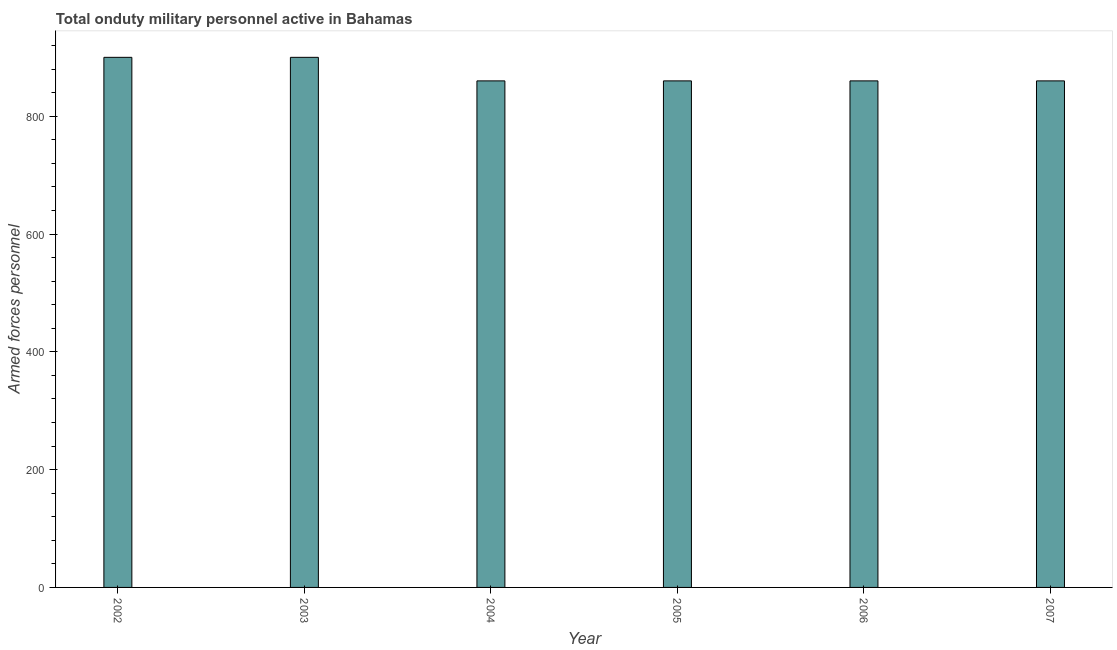Does the graph contain any zero values?
Offer a very short reply. No. Does the graph contain grids?
Offer a terse response. No. What is the title of the graph?
Your response must be concise. Total onduty military personnel active in Bahamas. What is the label or title of the Y-axis?
Provide a short and direct response. Armed forces personnel. What is the number of armed forces personnel in 2003?
Your answer should be very brief. 900. Across all years, what is the maximum number of armed forces personnel?
Provide a succinct answer. 900. Across all years, what is the minimum number of armed forces personnel?
Make the answer very short. 860. In which year was the number of armed forces personnel maximum?
Offer a very short reply. 2002. What is the sum of the number of armed forces personnel?
Keep it short and to the point. 5240. What is the difference between the number of armed forces personnel in 2002 and 2003?
Ensure brevity in your answer.  0. What is the average number of armed forces personnel per year?
Your response must be concise. 873. What is the median number of armed forces personnel?
Give a very brief answer. 860. Do a majority of the years between 2006 and 2005 (inclusive) have number of armed forces personnel greater than 40 ?
Give a very brief answer. No. What is the ratio of the number of armed forces personnel in 2003 to that in 2004?
Your answer should be compact. 1.05. Is the number of armed forces personnel in 2003 less than that in 2007?
Make the answer very short. No. How many bars are there?
Provide a succinct answer. 6. Are all the bars in the graph horizontal?
Provide a short and direct response. No. What is the difference between two consecutive major ticks on the Y-axis?
Your response must be concise. 200. Are the values on the major ticks of Y-axis written in scientific E-notation?
Provide a succinct answer. No. What is the Armed forces personnel in 2002?
Your answer should be compact. 900. What is the Armed forces personnel of 2003?
Make the answer very short. 900. What is the Armed forces personnel in 2004?
Give a very brief answer. 860. What is the Armed forces personnel in 2005?
Offer a terse response. 860. What is the Armed forces personnel in 2006?
Your response must be concise. 860. What is the Armed forces personnel in 2007?
Your answer should be compact. 860. What is the difference between the Armed forces personnel in 2002 and 2007?
Ensure brevity in your answer.  40. What is the difference between the Armed forces personnel in 2003 and 2004?
Make the answer very short. 40. What is the difference between the Armed forces personnel in 2003 and 2005?
Your answer should be very brief. 40. What is the difference between the Armed forces personnel in 2003 and 2007?
Ensure brevity in your answer.  40. What is the difference between the Armed forces personnel in 2004 and 2005?
Your answer should be very brief. 0. What is the difference between the Armed forces personnel in 2005 and 2006?
Give a very brief answer. 0. What is the ratio of the Armed forces personnel in 2002 to that in 2004?
Offer a terse response. 1.05. What is the ratio of the Armed forces personnel in 2002 to that in 2005?
Provide a short and direct response. 1.05. What is the ratio of the Armed forces personnel in 2002 to that in 2006?
Offer a very short reply. 1.05. What is the ratio of the Armed forces personnel in 2002 to that in 2007?
Provide a short and direct response. 1.05. What is the ratio of the Armed forces personnel in 2003 to that in 2004?
Make the answer very short. 1.05. What is the ratio of the Armed forces personnel in 2003 to that in 2005?
Make the answer very short. 1.05. What is the ratio of the Armed forces personnel in 2003 to that in 2006?
Keep it short and to the point. 1.05. What is the ratio of the Armed forces personnel in 2003 to that in 2007?
Make the answer very short. 1.05. What is the ratio of the Armed forces personnel in 2004 to that in 2005?
Ensure brevity in your answer.  1. What is the ratio of the Armed forces personnel in 2004 to that in 2006?
Your answer should be compact. 1. What is the ratio of the Armed forces personnel in 2005 to that in 2006?
Your answer should be very brief. 1. What is the ratio of the Armed forces personnel in 2005 to that in 2007?
Keep it short and to the point. 1. 